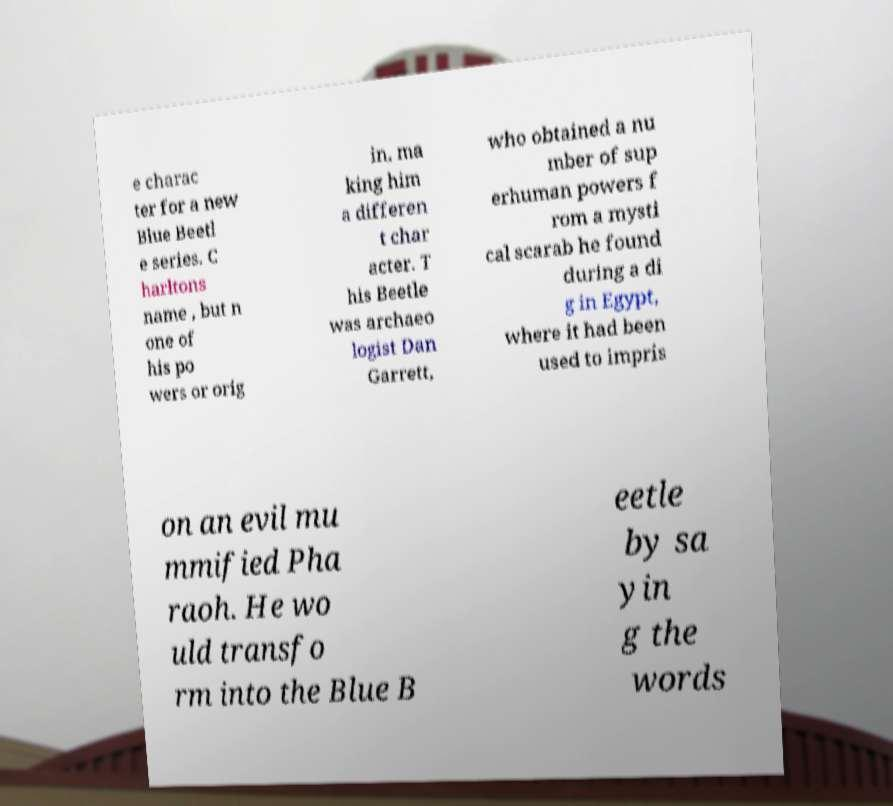Please read and relay the text visible in this image. What does it say? e charac ter for a new Blue Beetl e series. C harltons name , but n one of his po wers or orig in, ma king him a differen t char acter. T his Beetle was archaeo logist Dan Garrett, who obtained a nu mber of sup erhuman powers f rom a mysti cal scarab he found during a di g in Egypt, where it had been used to impris on an evil mu mmified Pha raoh. He wo uld transfo rm into the Blue B eetle by sa yin g the words 